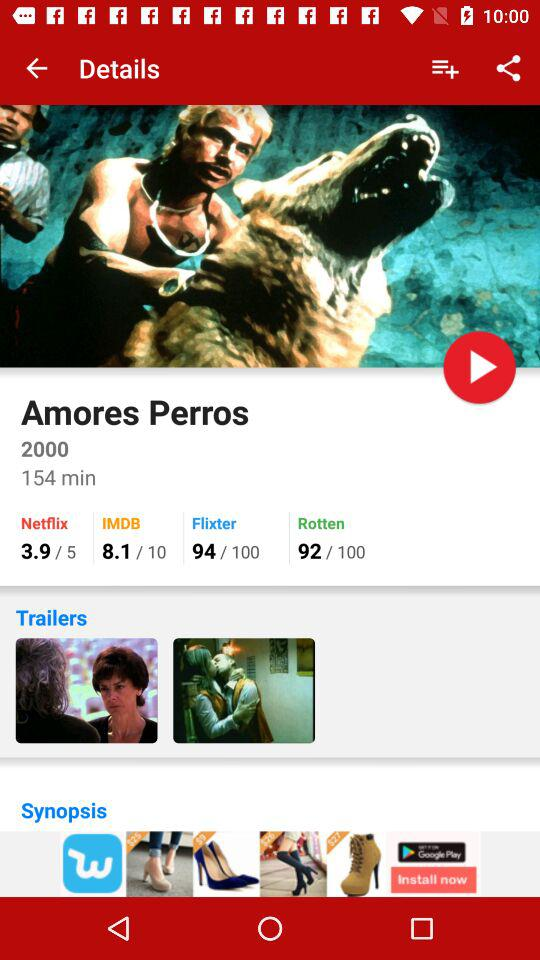What is the IMDB score of the Amores Perros? The IMDB score of the Amores Perros is 8.1. 